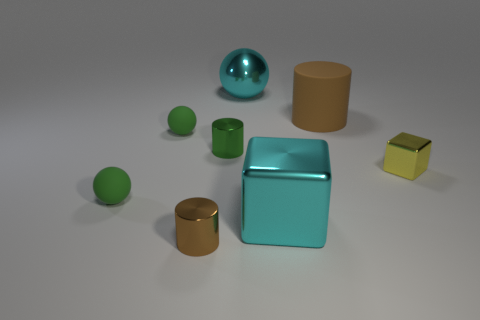Subtract all purple cylinders. Subtract all brown spheres. How many cylinders are left? 3 Add 2 large cyan spheres. How many objects exist? 10 Subtract all spheres. How many objects are left? 5 Subtract 1 yellow blocks. How many objects are left? 7 Subtract all red metallic things. Subtract all brown rubber cylinders. How many objects are left? 7 Add 6 small balls. How many small balls are left? 8 Add 5 big cyan metal blocks. How many big cyan metal blocks exist? 6 